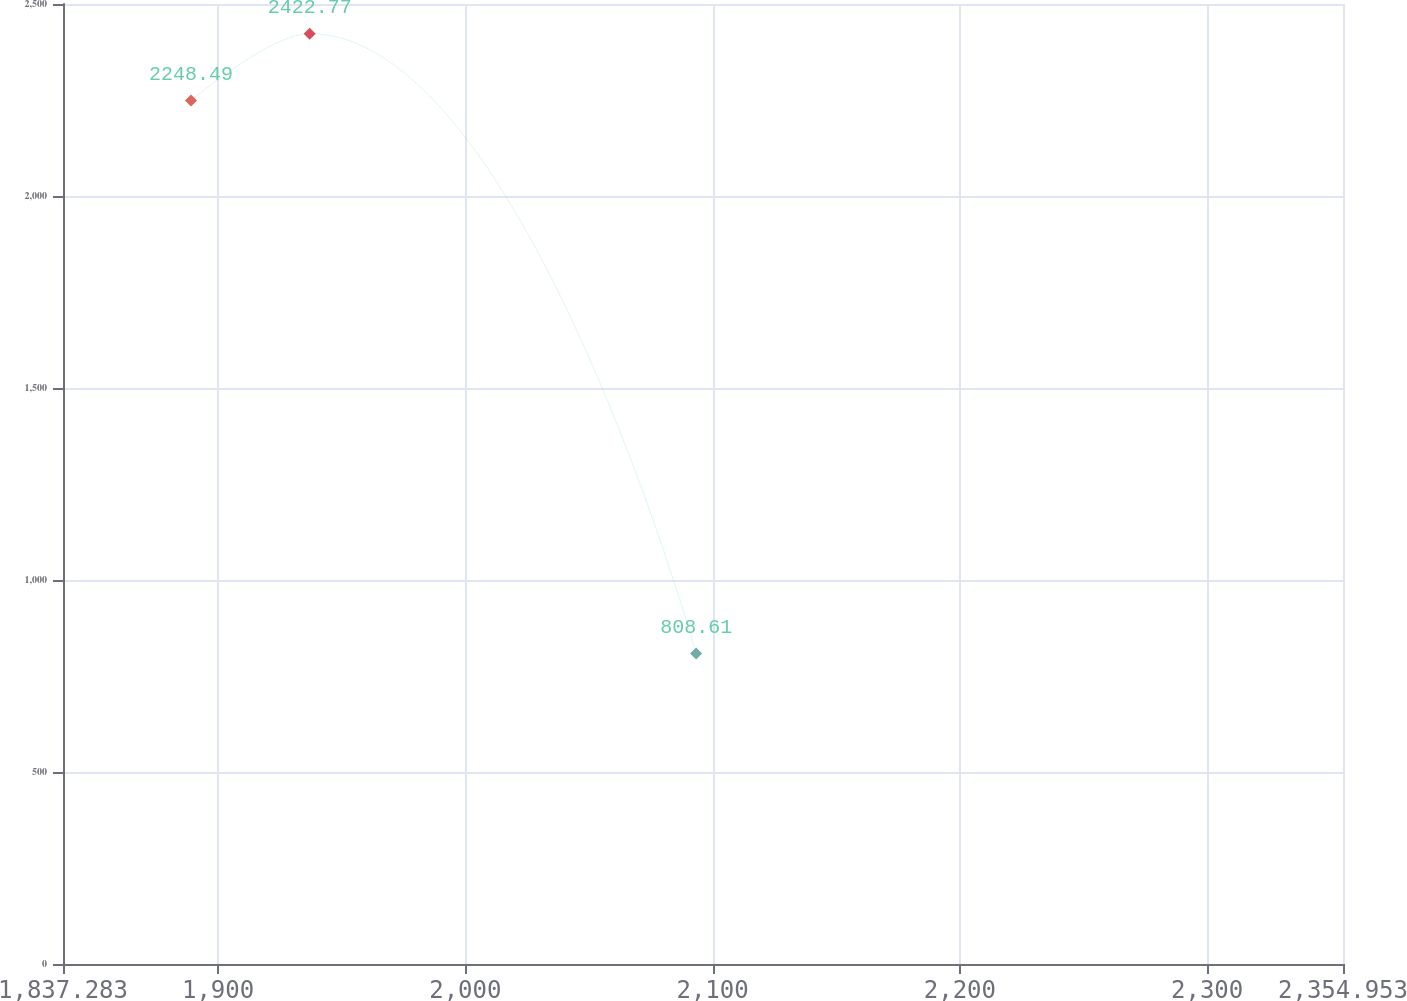Convert chart. <chart><loc_0><loc_0><loc_500><loc_500><line_chart><ecel><fcel>Unnamed: 1<nl><fcel>1889.05<fcel>2248.49<nl><fcel>1937.06<fcel>2422.77<nl><fcel>2093.35<fcel>808.61<nl><fcel>2358.71<fcel>595.11<nl><fcel>2406.72<fcel>982.89<nl></chart> 